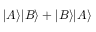<formula> <loc_0><loc_0><loc_500><loc_500>| A \rangle | B \rangle + | B \rangle | A \rangle</formula> 